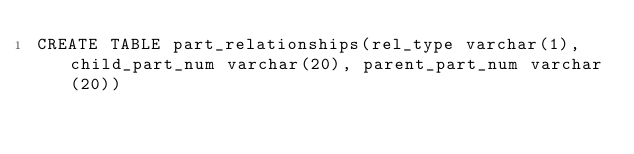Convert code to text. <code><loc_0><loc_0><loc_500><loc_500><_SQL_>CREATE TABLE part_relationships(rel_type varchar(1), child_part_num varchar(20), parent_part_num varchar(20))</code> 